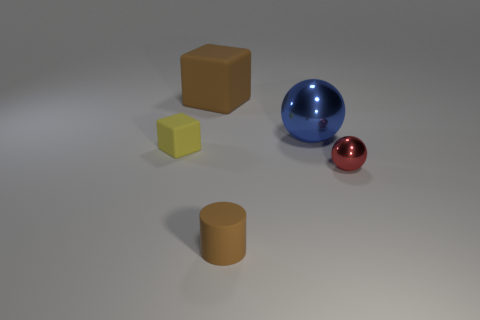Add 2 small blue shiny blocks. How many objects exist? 7 Subtract all spheres. How many objects are left? 3 Add 3 big cubes. How many big cubes exist? 4 Subtract 0 yellow balls. How many objects are left? 5 Subtract all matte balls. Subtract all small cylinders. How many objects are left? 4 Add 4 small brown cylinders. How many small brown cylinders are left? 5 